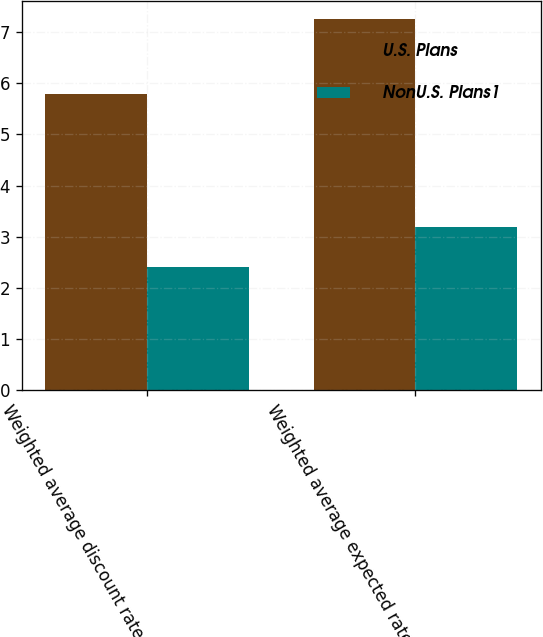Convert chart to OTSL. <chart><loc_0><loc_0><loc_500><loc_500><stacked_bar_chart><ecel><fcel>Weighted average discount rate<fcel>Weighted average expected rate<nl><fcel>U.S. Plans<fcel>5.8<fcel>7.25<nl><fcel>NonU.S. Plans1<fcel>2.4<fcel>3.19<nl></chart> 